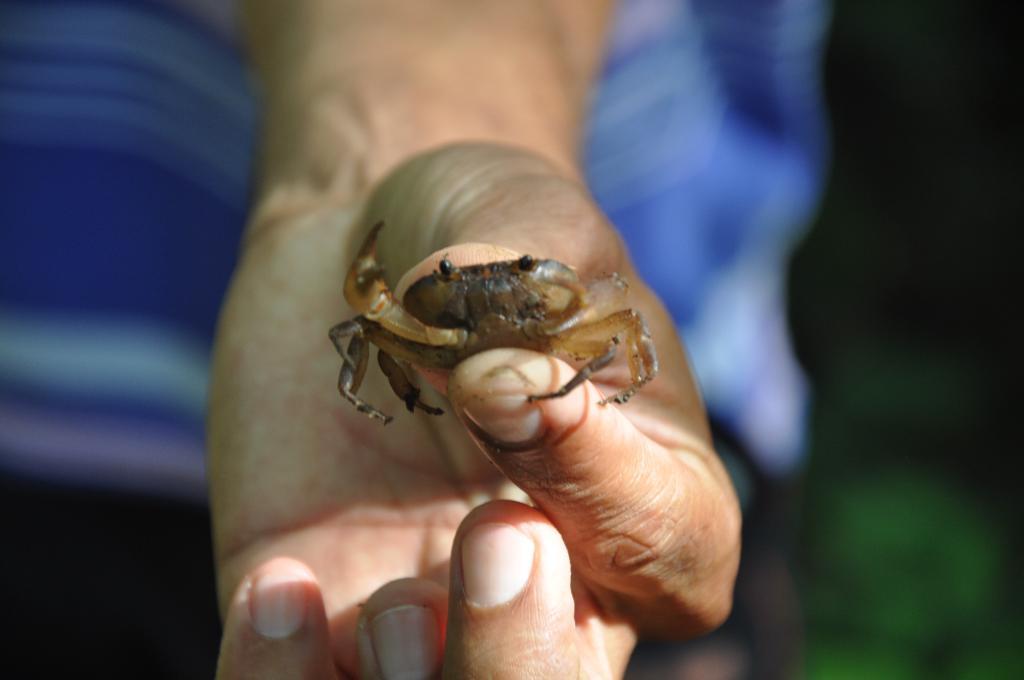Could you give a brief overview of what you see in this image? In the image we can see a hand holding a crab with fingers. In the background it is blur. 